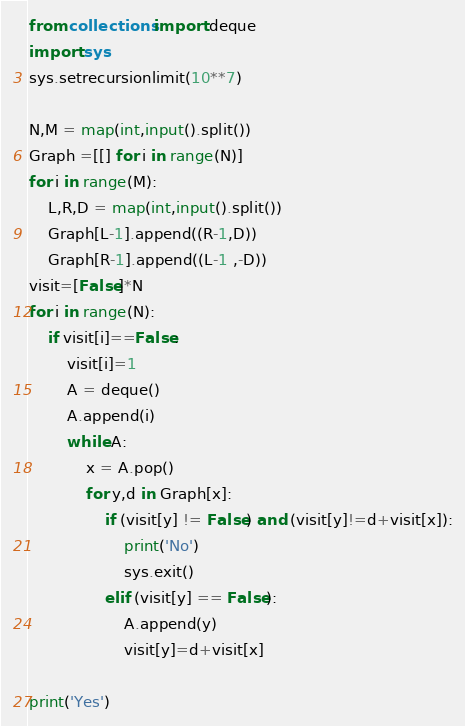Convert code to text. <code><loc_0><loc_0><loc_500><loc_500><_Python_>from collections import deque
import sys
sys.setrecursionlimit(10**7)

N,M = map(int,input().split())
Graph =[[] for i in range(N)]
for i in range(M):
    L,R,D = map(int,input().split())
    Graph[L-1].append((R-1,D))
    Graph[R-1].append((L-1 ,-D))
visit=[False]*N
for i in range(N):
    if visit[i]==False:
        visit[i]=1
        A = deque()
        A.append(i)
        while A:
            x = A.pop()
            for y,d in Graph[x]:
                if (visit[y] != False) and (visit[y]!=d+visit[x]):
                    print('No')
                    sys.exit()
                elif (visit[y] == False):
                    A.append(y)
                    visit[y]=d+visit[x] 
    
print('Yes')</code> 